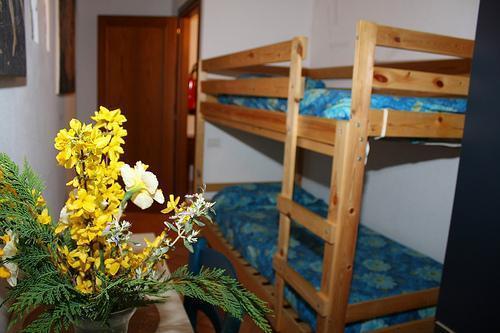How many beds are there?
Give a very brief answer. 2. 